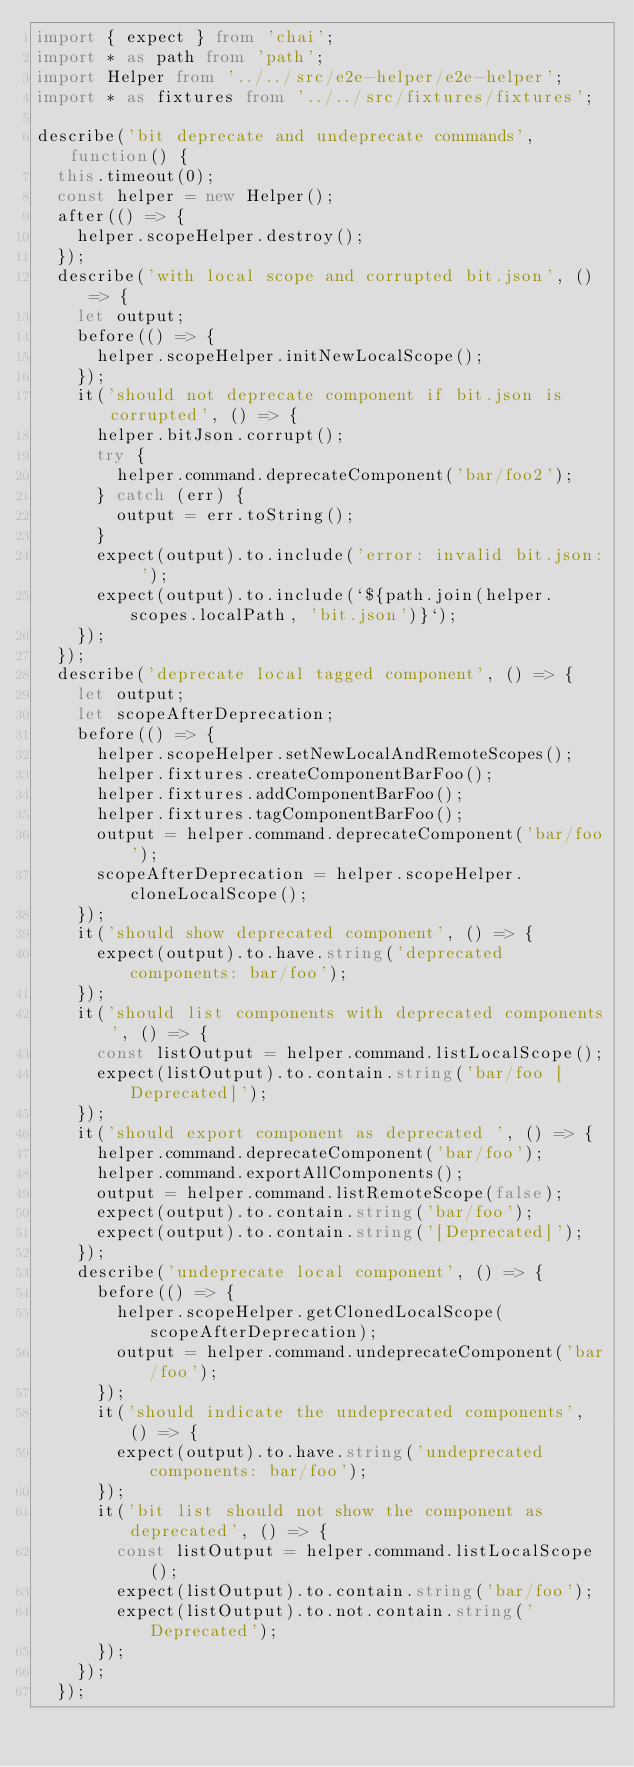Convert code to text. <code><loc_0><loc_0><loc_500><loc_500><_TypeScript_>import { expect } from 'chai';
import * as path from 'path';
import Helper from '../../src/e2e-helper/e2e-helper';
import * as fixtures from '../../src/fixtures/fixtures';

describe('bit deprecate and undeprecate commands', function() {
  this.timeout(0);
  const helper = new Helper();
  after(() => {
    helper.scopeHelper.destroy();
  });
  describe('with local scope and corrupted bit.json', () => {
    let output;
    before(() => {
      helper.scopeHelper.initNewLocalScope();
    });
    it('should not deprecate component if bit.json is corrupted', () => {
      helper.bitJson.corrupt();
      try {
        helper.command.deprecateComponent('bar/foo2');
      } catch (err) {
        output = err.toString();
      }
      expect(output).to.include('error: invalid bit.json: ');
      expect(output).to.include(`${path.join(helper.scopes.localPath, 'bit.json')}`);
    });
  });
  describe('deprecate local tagged component', () => {
    let output;
    let scopeAfterDeprecation;
    before(() => {
      helper.scopeHelper.setNewLocalAndRemoteScopes();
      helper.fixtures.createComponentBarFoo();
      helper.fixtures.addComponentBarFoo();
      helper.fixtures.tagComponentBarFoo();
      output = helper.command.deprecateComponent('bar/foo');
      scopeAfterDeprecation = helper.scopeHelper.cloneLocalScope();
    });
    it('should show deprecated component', () => {
      expect(output).to.have.string('deprecated components: bar/foo');
    });
    it('should list components with deprecated components', () => {
      const listOutput = helper.command.listLocalScope();
      expect(listOutput).to.contain.string('bar/foo [Deprecated]');
    });
    it('should export component as deprecated ', () => {
      helper.command.deprecateComponent('bar/foo');
      helper.command.exportAllComponents();
      output = helper.command.listRemoteScope(false);
      expect(output).to.contain.string('bar/foo');
      expect(output).to.contain.string('[Deprecated]');
    });
    describe('undeprecate local component', () => {
      before(() => {
        helper.scopeHelper.getClonedLocalScope(scopeAfterDeprecation);
        output = helper.command.undeprecateComponent('bar/foo');
      });
      it('should indicate the undeprecated components', () => {
        expect(output).to.have.string('undeprecated components: bar/foo');
      });
      it('bit list should not show the component as deprecated', () => {
        const listOutput = helper.command.listLocalScope();
        expect(listOutput).to.contain.string('bar/foo');
        expect(listOutput).to.not.contain.string('Deprecated');
      });
    });
  });</code> 